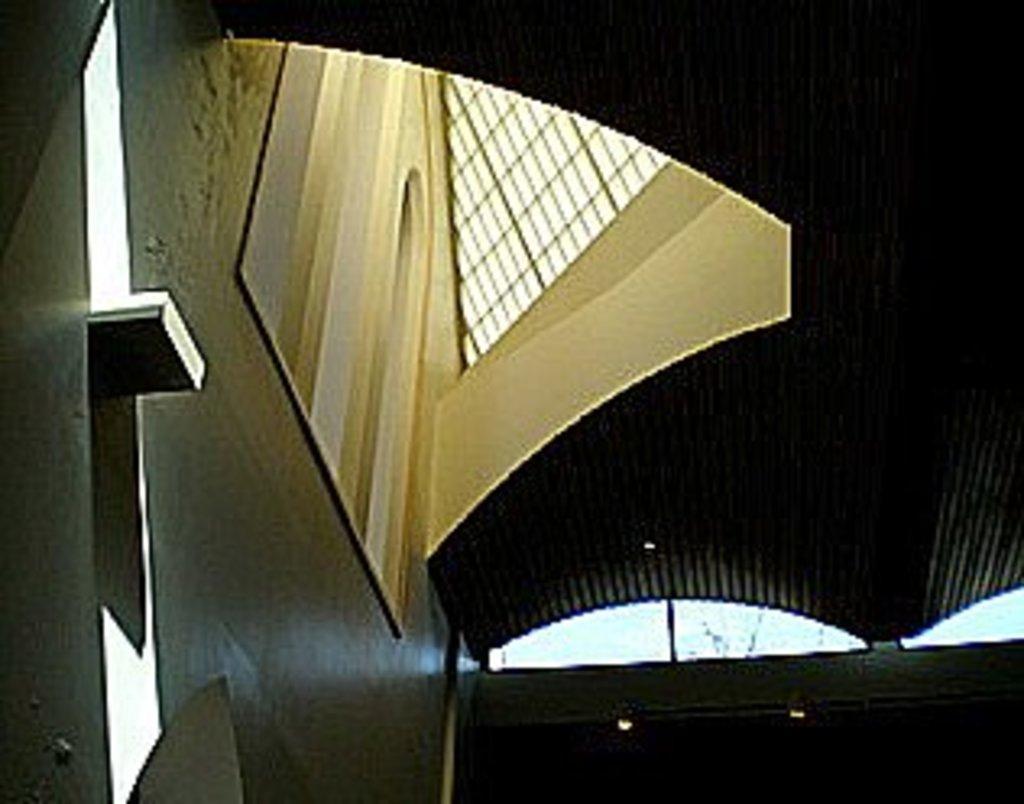In one or two sentences, can you explain what this image depicts? This is a picture of inside of a building, in this image at the top there might be a ceiling and also we could see some lights, poles and some objects. 